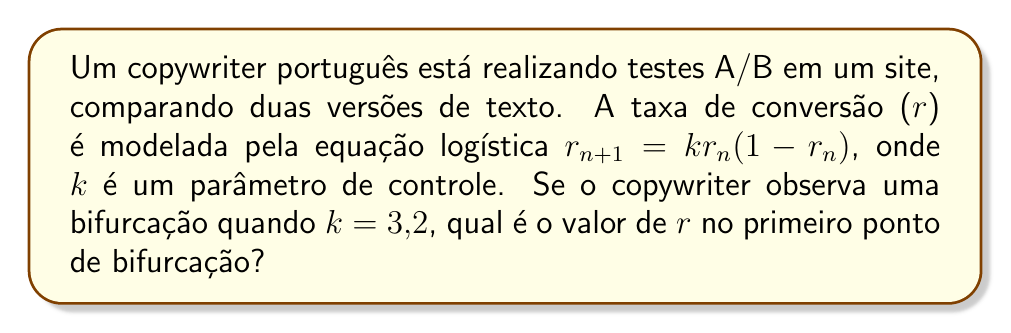Can you solve this math problem? Para resolver este problema, seguiremos estes passos:

1) A equação logística $r_{n+1} = kr_n(1-r_n)$ é um exemplo clássico de um sistema caótico que exibe bifurcações.

2) O primeiro ponto de bifurcação ocorre quando k = 3. Neste ponto, o sistema passa de um ponto fixo estável para um ciclo de período 2.

3) Para encontrar o valor de r no primeiro ponto de bifurcação, precisamos resolver a equação do ponto fixo:

   $r = kr(1-r)$

4) Expandindo:
   
   $r = kr - kr^2$

5) Rearranjando:

   $kr^2 - kr + r = 0$
   $r(kr - k + 1) = 0$

6) As soluções são $r = 0$ e $r = \frac{k-1}{k}$

7) A solução não-trivial é $r = \frac{k-1}{k}$

8) Substituindo k = 3 (o valor no primeiro ponto de bifurcação):

   $r = \frac{3-1}{3} = \frac{2}{3} \approx 0.6667$

Portanto, no primeiro ponto de bifurcação, o valor de r é aproximadamente 0,6667.
Answer: $\frac{2}{3}$ 